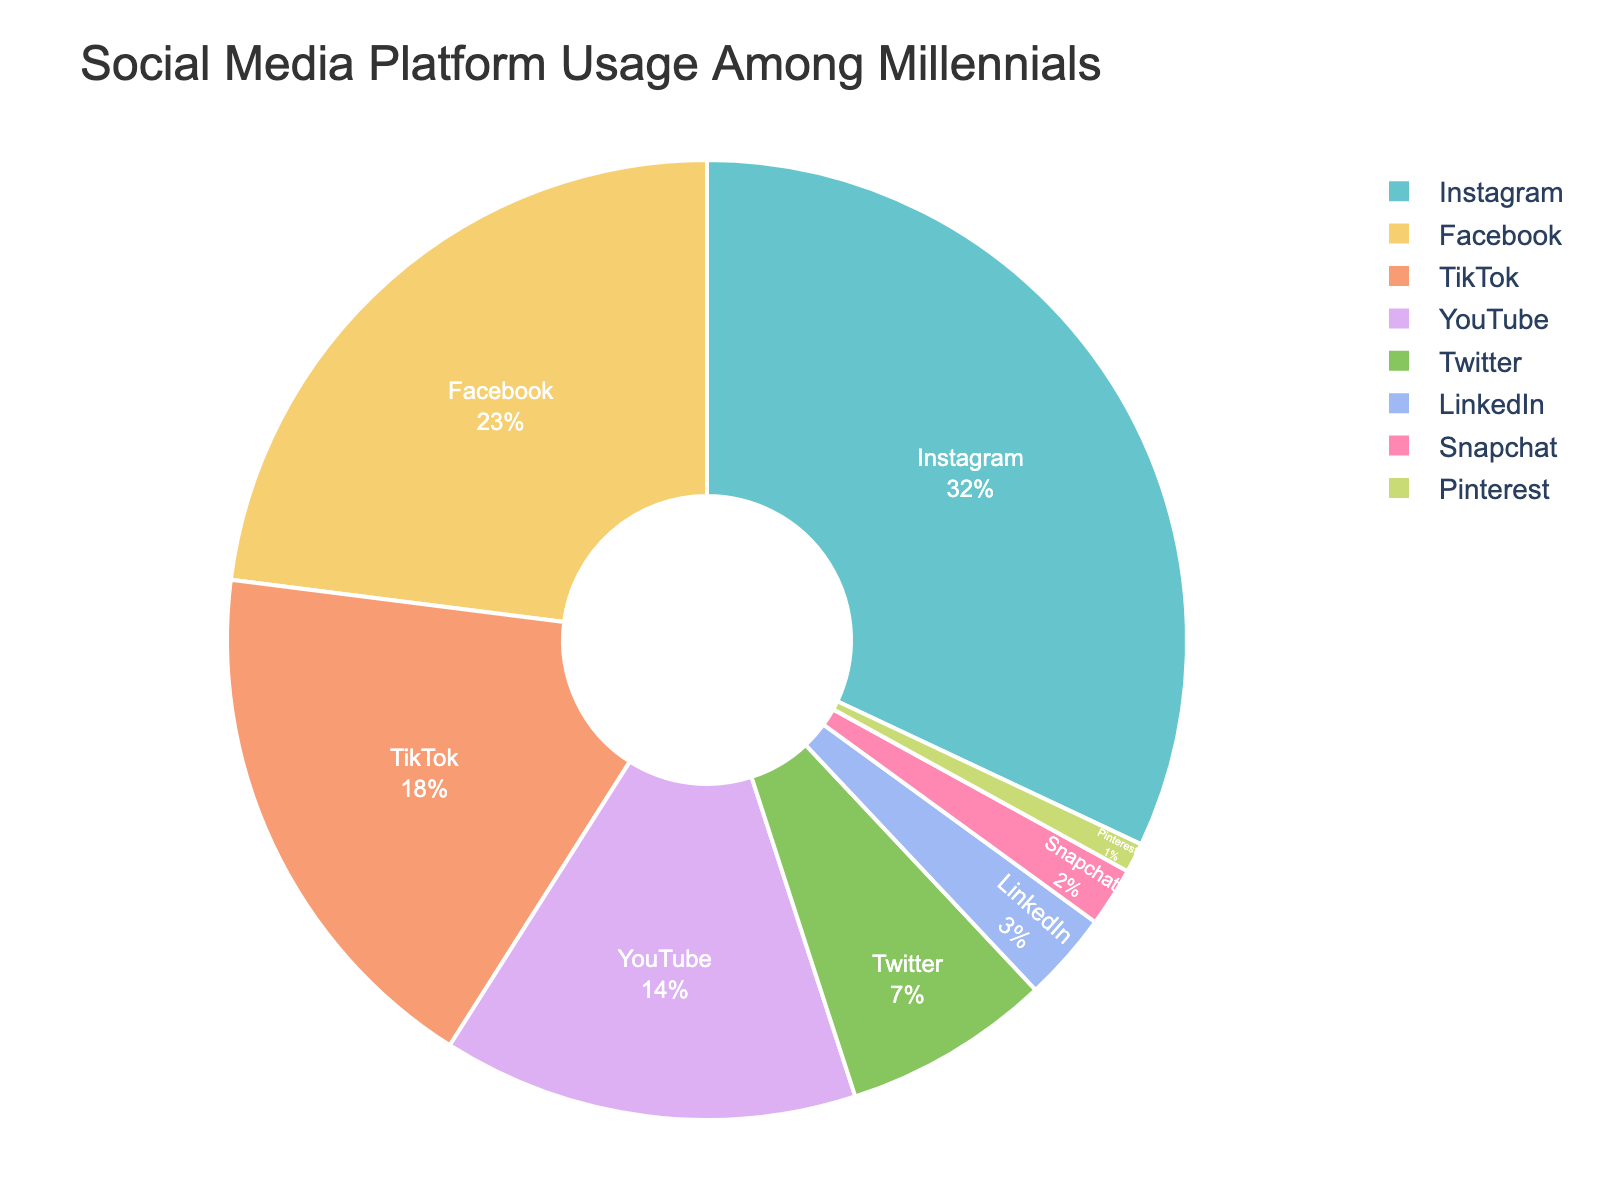What is the largest social media platform among millennials according to the pie chart? The pie chart shows the percentages of different social media platforms used by millennials. The platform with the largest percentage is the one used by the most millennials. Looking at the chart, Instagram has the highest percentage at 32%.
Answer: Instagram Which social media platform is used less by millennials, Twitter or TikTok? The pie chart provides the usage percentages for different social media platforms among millennials. To determine which of Twitter or TikTok has a lower percentage, compare their individual percentages. Twitter has 7%, whereas TikTok has 18%. Thus, Twitter is used less.
Answer: Twitter What is the combined percentage of Instagram and Facebook usage among millennials? To find the combined percentage of Instagram and Facebook, we need to add their individual percentages from the pie chart. Instagram has 32% and Facebook has 23%. Adding these together, 32% + 23% = 55%.
Answer: 55% By how much does the percentage of YouTube usage exceed LinkedIn usage among millennials? To determine how much YouTube usage exceeds LinkedIn usage, subtract the percentage of LinkedIn from the percentage of YouTube. The pie chart shows YouTube at 14% and LinkedIn at 3%. Thus, 14% - 3% = 11%.
Answer: 11% What is the difference in usage percentage between the platform with the highest usage and the one with the lowest among millennials? The platform with the highest usage is Instagram at 32%, and the one with the lowest is Pinterest at 1%. The difference is calculated by subtracting the lowest percentage from the highest percentage: 32% - 1% = 31%.
Answer: 31% How many platforms have a usage percentage less than 10% among millennials? To find the number of platforms with a usage percentage less than 10%, we need to look at the individual percentages on the pie chart. The platforms with percentages less than 10% are Twitter (7%), LinkedIn (3%), Snapchat (2%), and Pinterest (1%). Counting these gives us 4 platforms.
Answer: 4 What fraction of millennials use TikTok compared to those who use Facebook? To find the fraction of TikTok users compared to Facebook users, use the percentages from the pie chart. TikTok usage is 18% and Facebook usage is 23%. The fraction is 18/23, which can be simplified to a ratio but is generally left as a fraction.
Answer: 18/23 Which social media platforms have double-digit usage percentages among millennials? Double-digit percentages are those greater than or equal to 10%. From the pie chart, the platforms with such percentages are Instagram (32%), Facebook (23%), TikTok (18%), and YouTube (14%).
Answer: Instagram, Facebook, TikTok, YouTube If usage of Instagram dropped by 5%, would Facebook then become the most used platform? If Instagram's usage dropped by 5%, its new percentage would be 32% - 5% = 27%. Facebook's usage is 23%. Even with this drop, Instagram's 27% would still be greater than Facebook's 23%, so Facebook would not become the most used platform.
Answer: No 